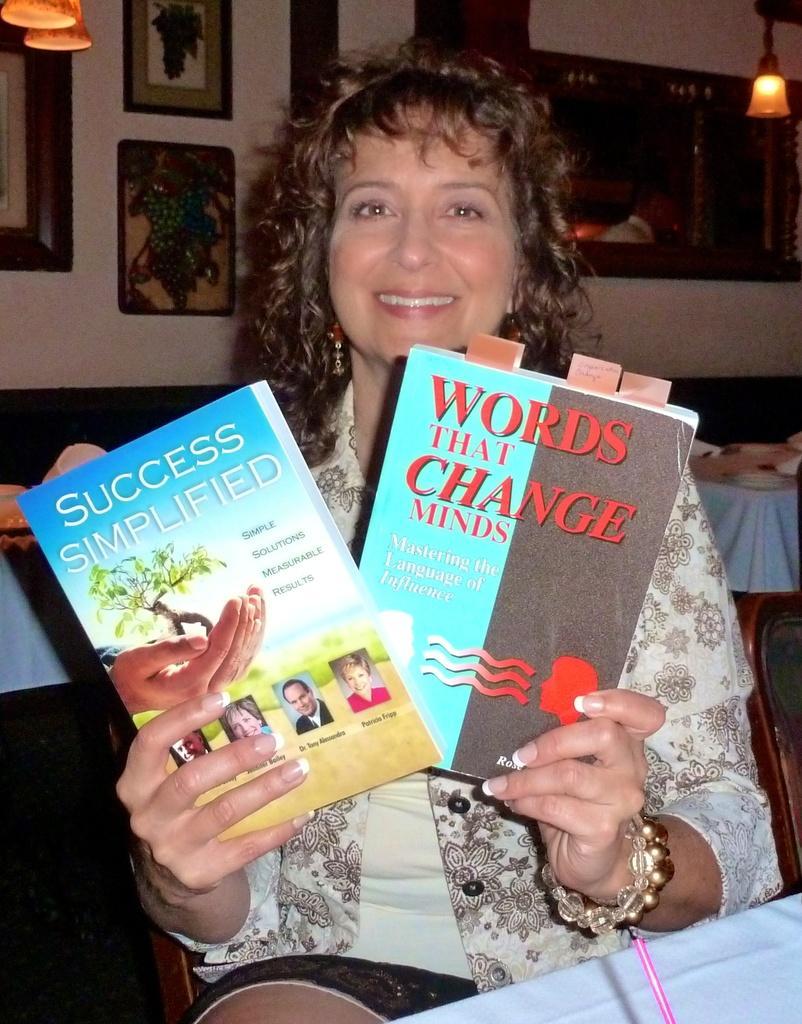Can you describe this image briefly? In this picture we can see a woman sitting on a chair and holding books with her hands and smiling and in the background we can see tables with some objects on it, wall with frames, lights. 